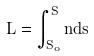<formula> <loc_0><loc_0><loc_500><loc_500>L = \int _ { S _ { o } } ^ { S } n d s</formula> 